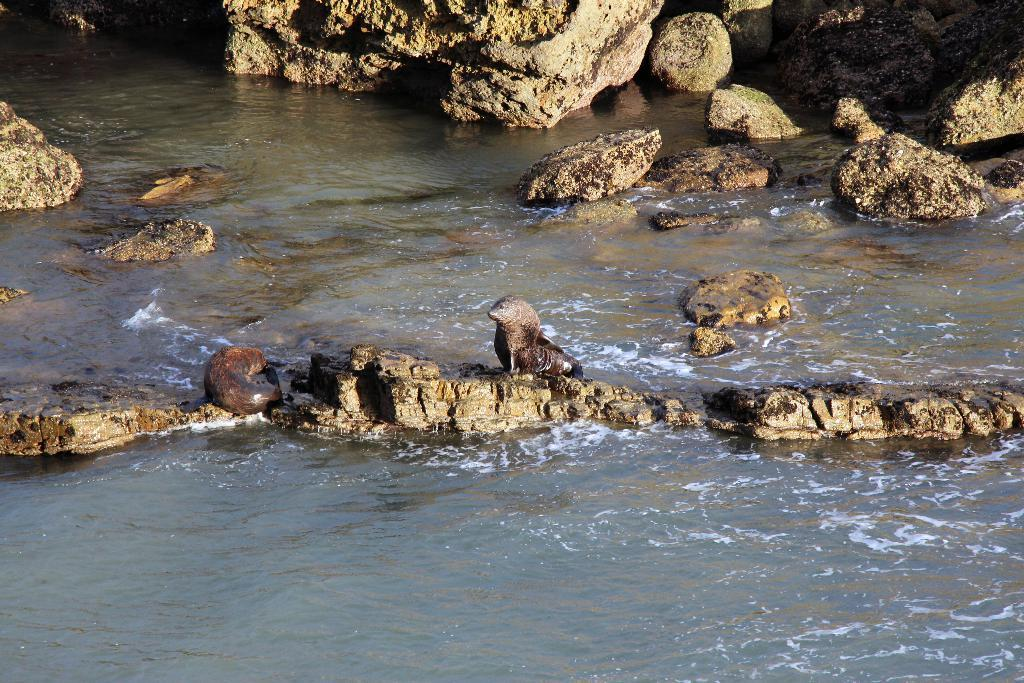What type of living organisms can be seen in the image? There are animals in the image. What is the color of the animals? The animals are brown in color. What natural element is visible in the image? There is water visible in the image. What type of geological formation is present in the image? There are rocks in the image. What type of town can be seen in the image? There is no town present in the image; it features animals, water, and rocks. How many ants are visible in the image? There are no ants visible in the image; it features animals, water, and rocks. 